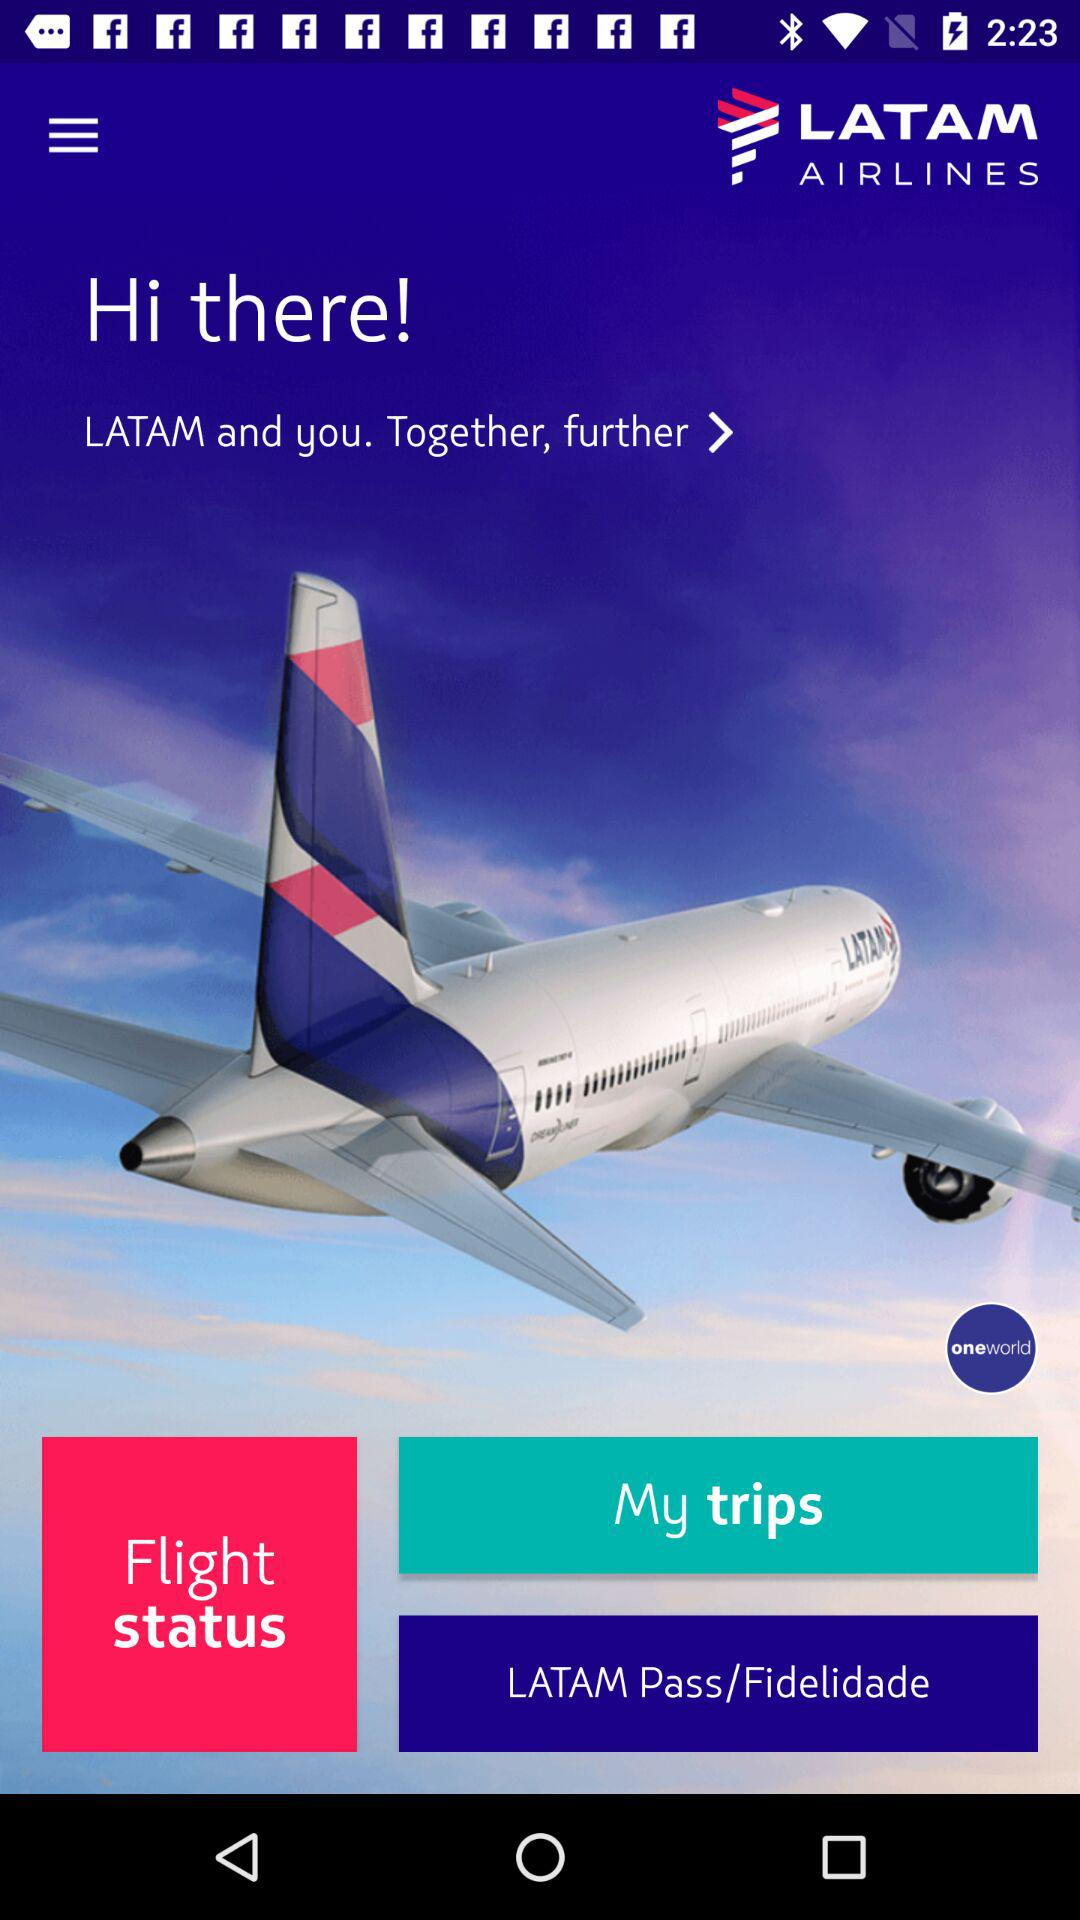What is the airline's name? The airline's name is Latam Airlines. 